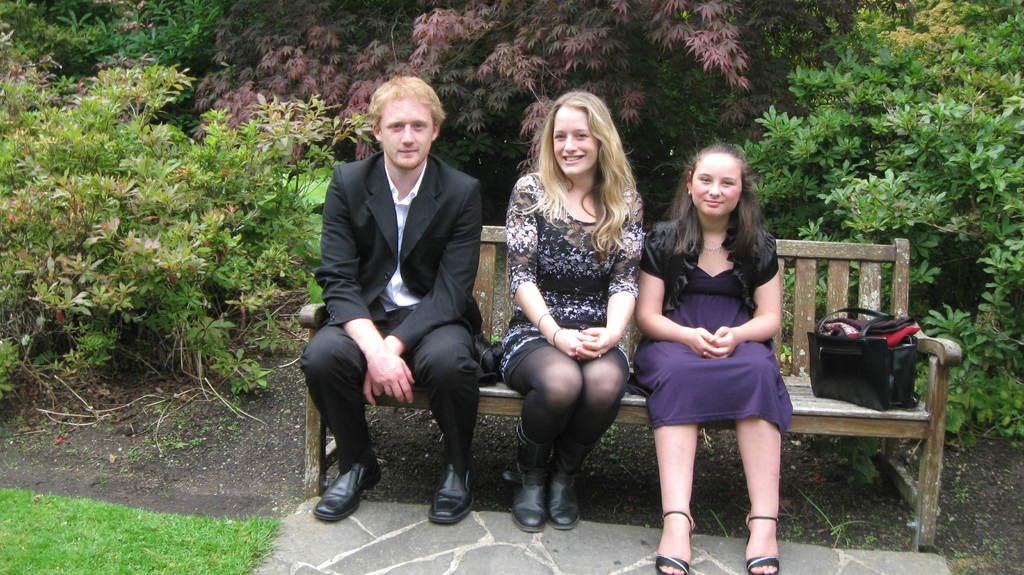How many people are sitting on the bench in the image? There are three people sitting on the bench in the image. What is placed on the bench with the people? There is a bag placed on the bench. What can be seen in the background of the image? There are trees in the background of the image. What type of ground is visible at the bottom of the image? Grass is present at the bottom of the image. Are the people on the bench holding hands in the image? There is no indication in the image that the people are holding hands. 